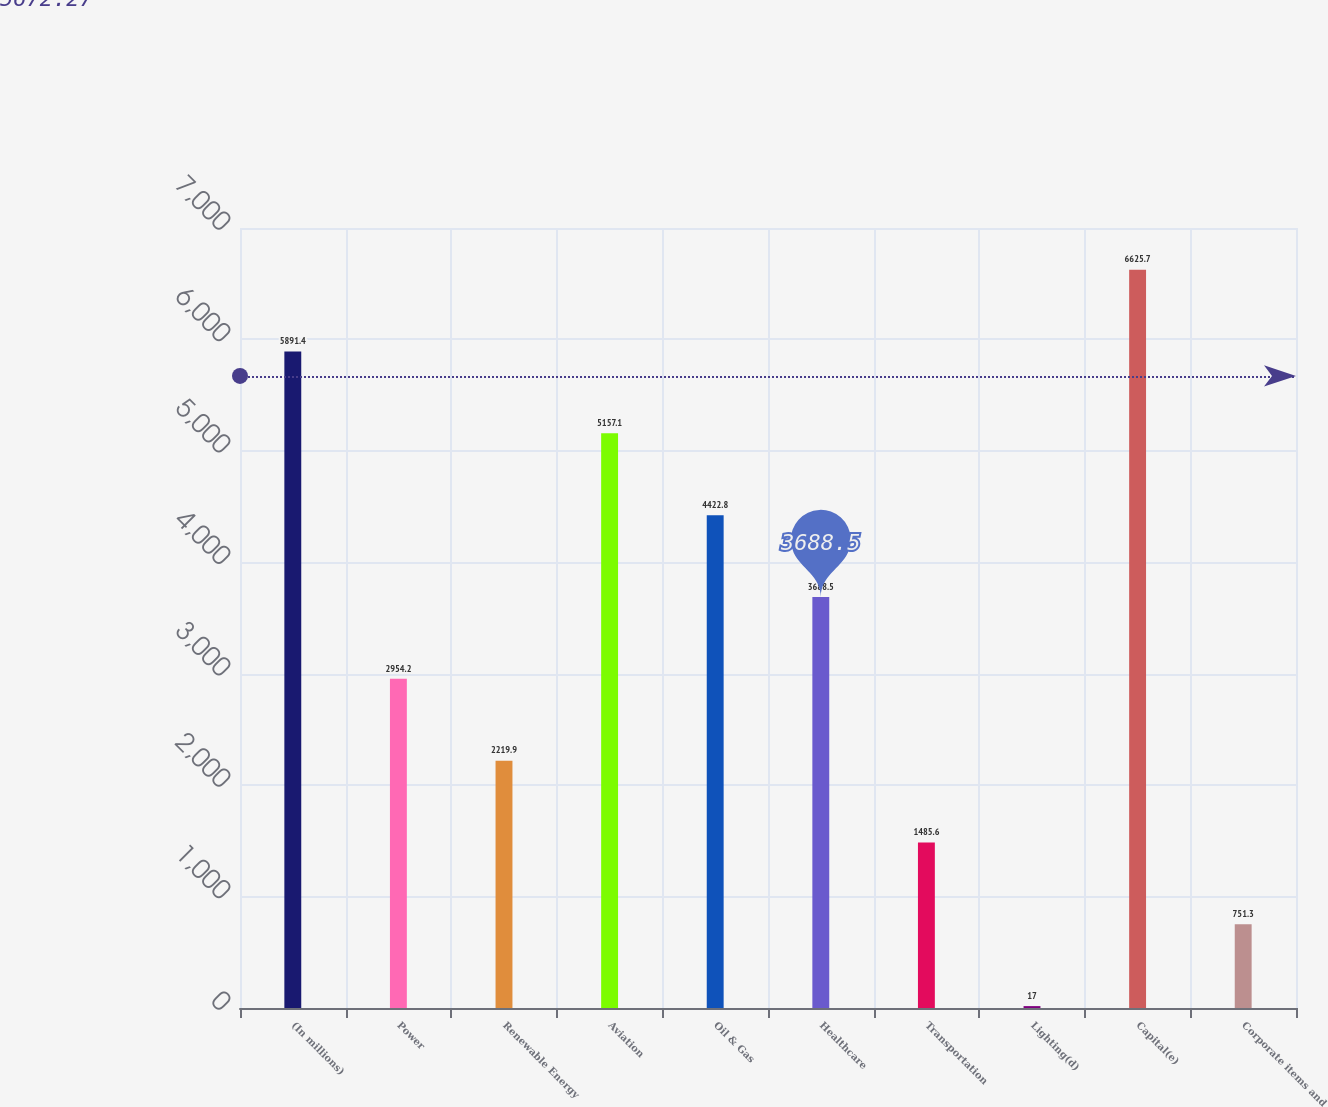Convert chart. <chart><loc_0><loc_0><loc_500><loc_500><bar_chart><fcel>(In millions)<fcel>Power<fcel>Renewable Energy<fcel>Aviation<fcel>Oil & Gas<fcel>Healthcare<fcel>Transportation<fcel>Lighting(d)<fcel>Capital(e)<fcel>Corporate items and<nl><fcel>5891.4<fcel>2954.2<fcel>2219.9<fcel>5157.1<fcel>4422.8<fcel>3688.5<fcel>1485.6<fcel>17<fcel>6625.7<fcel>751.3<nl></chart> 